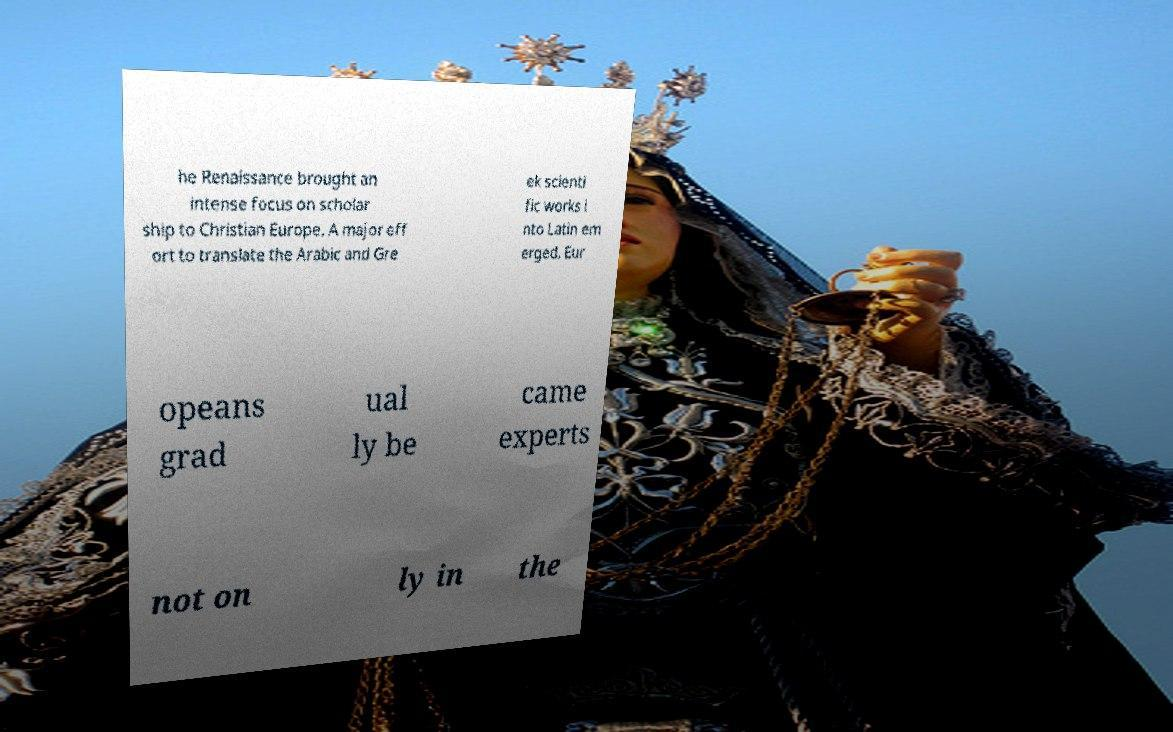Could you assist in decoding the text presented in this image and type it out clearly? he Renaissance brought an intense focus on scholar ship to Christian Europe. A major eff ort to translate the Arabic and Gre ek scienti fic works i nto Latin em erged. Eur opeans grad ual ly be came experts not on ly in the 